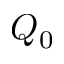<formula> <loc_0><loc_0><loc_500><loc_500>Q _ { 0 }</formula> 